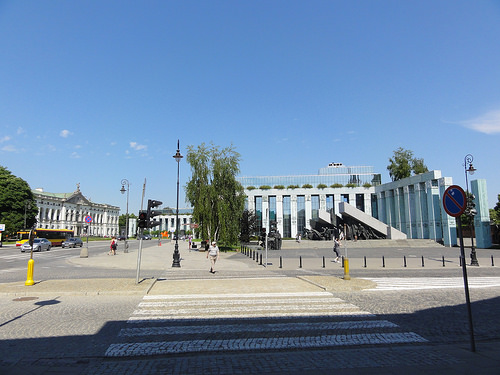<image>
Is the man to the left of the road? No. The man is not to the left of the road. From this viewpoint, they have a different horizontal relationship. 